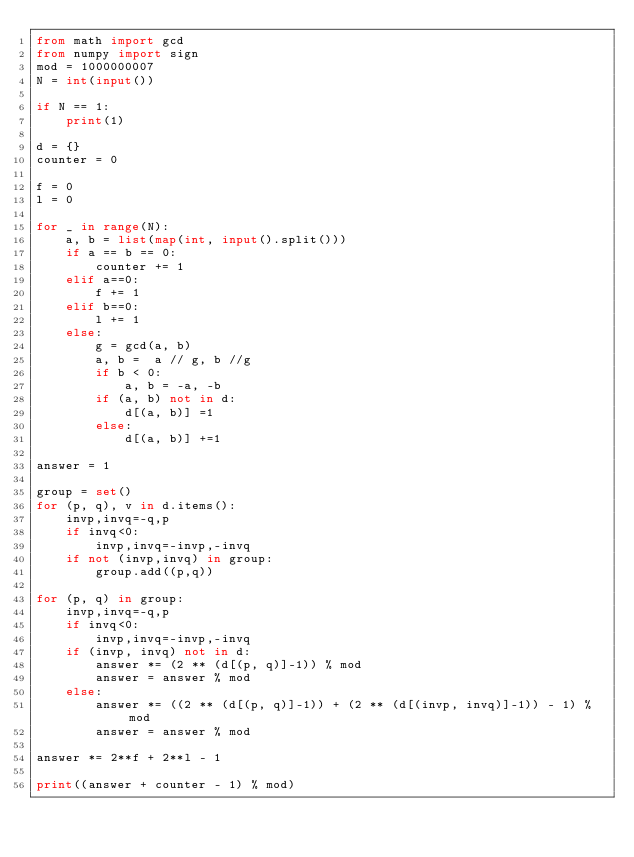<code> <loc_0><loc_0><loc_500><loc_500><_Python_>from math import gcd
from numpy import sign
mod = 1000000007
N = int(input())

if N == 1:
    print(1)
    
d = {}
counter = 0

f = 0
l = 0

for _ in range(N):
    a, b = list(map(int, input().split()))
    if a == b == 0:
        counter += 1
    elif a==0:
        f += 1
    elif b==0:
        l += 1
    else:
        g = gcd(a, b)
        a, b =  a // g, b //g
        if b < 0:
            a, b = -a, -b
        if (a, b) not in d:
            d[(a, b)] =1
        else:
            d[(a, b)] +=1

answer = 1

group = set()
for (p, q), v in d.items():
    invp,invq=-q,p
    if invq<0:
        invp,invq=-invp,-invq
    if not (invp,invq) in group:
        group.add((p,q))

for (p, q) in group:
    invp,invq=-q,p
    if invq<0:
        invp,invq=-invp,-invq
    if (invp, invq) not in d:
        answer *= (2 ** (d[(p, q)]-1)) % mod
        answer = answer % mod
    else:
        answer *= ((2 ** (d[(p, q)]-1)) + (2 ** (d[(invp, invq)]-1)) - 1) % mod
        answer = answer % mod
        
answer *= 2**f + 2**l - 1
    
print((answer + counter - 1) % mod)</code> 